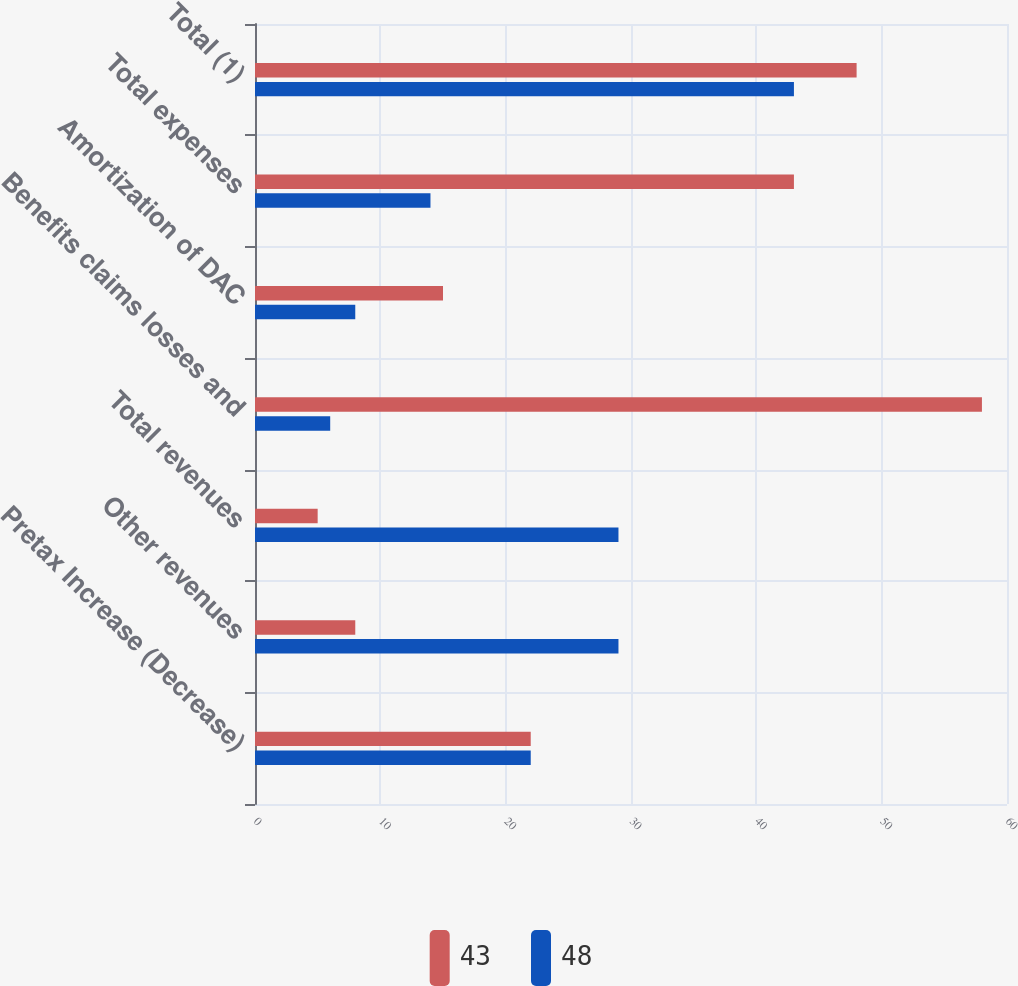Convert chart to OTSL. <chart><loc_0><loc_0><loc_500><loc_500><stacked_bar_chart><ecel><fcel>Pretax Increase (Decrease)<fcel>Other revenues<fcel>Total revenues<fcel>Benefits claims losses and<fcel>Amortization of DAC<fcel>Total expenses<fcel>Total (1)<nl><fcel>43<fcel>22<fcel>8<fcel>5<fcel>58<fcel>15<fcel>43<fcel>48<nl><fcel>48<fcel>22<fcel>29<fcel>29<fcel>6<fcel>8<fcel>14<fcel>43<nl></chart> 